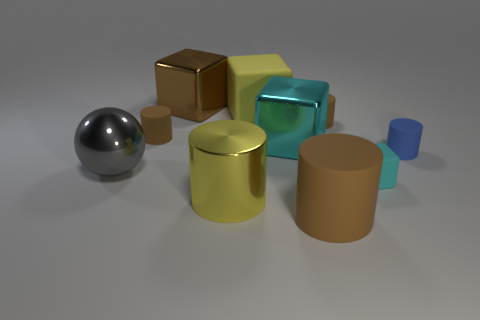How many things are either tiny brown shiny balls or large cubes?
Ensure brevity in your answer.  3. How many things are small purple rubber cylinders or large yellow things that are in front of the large ball?
Ensure brevity in your answer.  1. Are the large yellow cube and the blue thing made of the same material?
Offer a very short reply. Yes. How many other objects are there of the same material as the blue thing?
Your answer should be compact. 5. Are there more large gray metallic balls than large yellow things?
Keep it short and to the point. No. Do the brown rubber thing that is in front of the sphere and the big gray thing have the same shape?
Keep it short and to the point. No. Are there fewer yellow objects than tiny blue things?
Offer a very short reply. No. What is the material of the cyan cube that is the same size as the shiny sphere?
Offer a terse response. Metal. There is a metal ball; is its color the same as the rubber cube that is behind the small blue object?
Keep it short and to the point. No. Is the number of yellow rubber cubes in front of the tiny cyan rubber thing less than the number of big yellow things?
Your answer should be compact. Yes. 